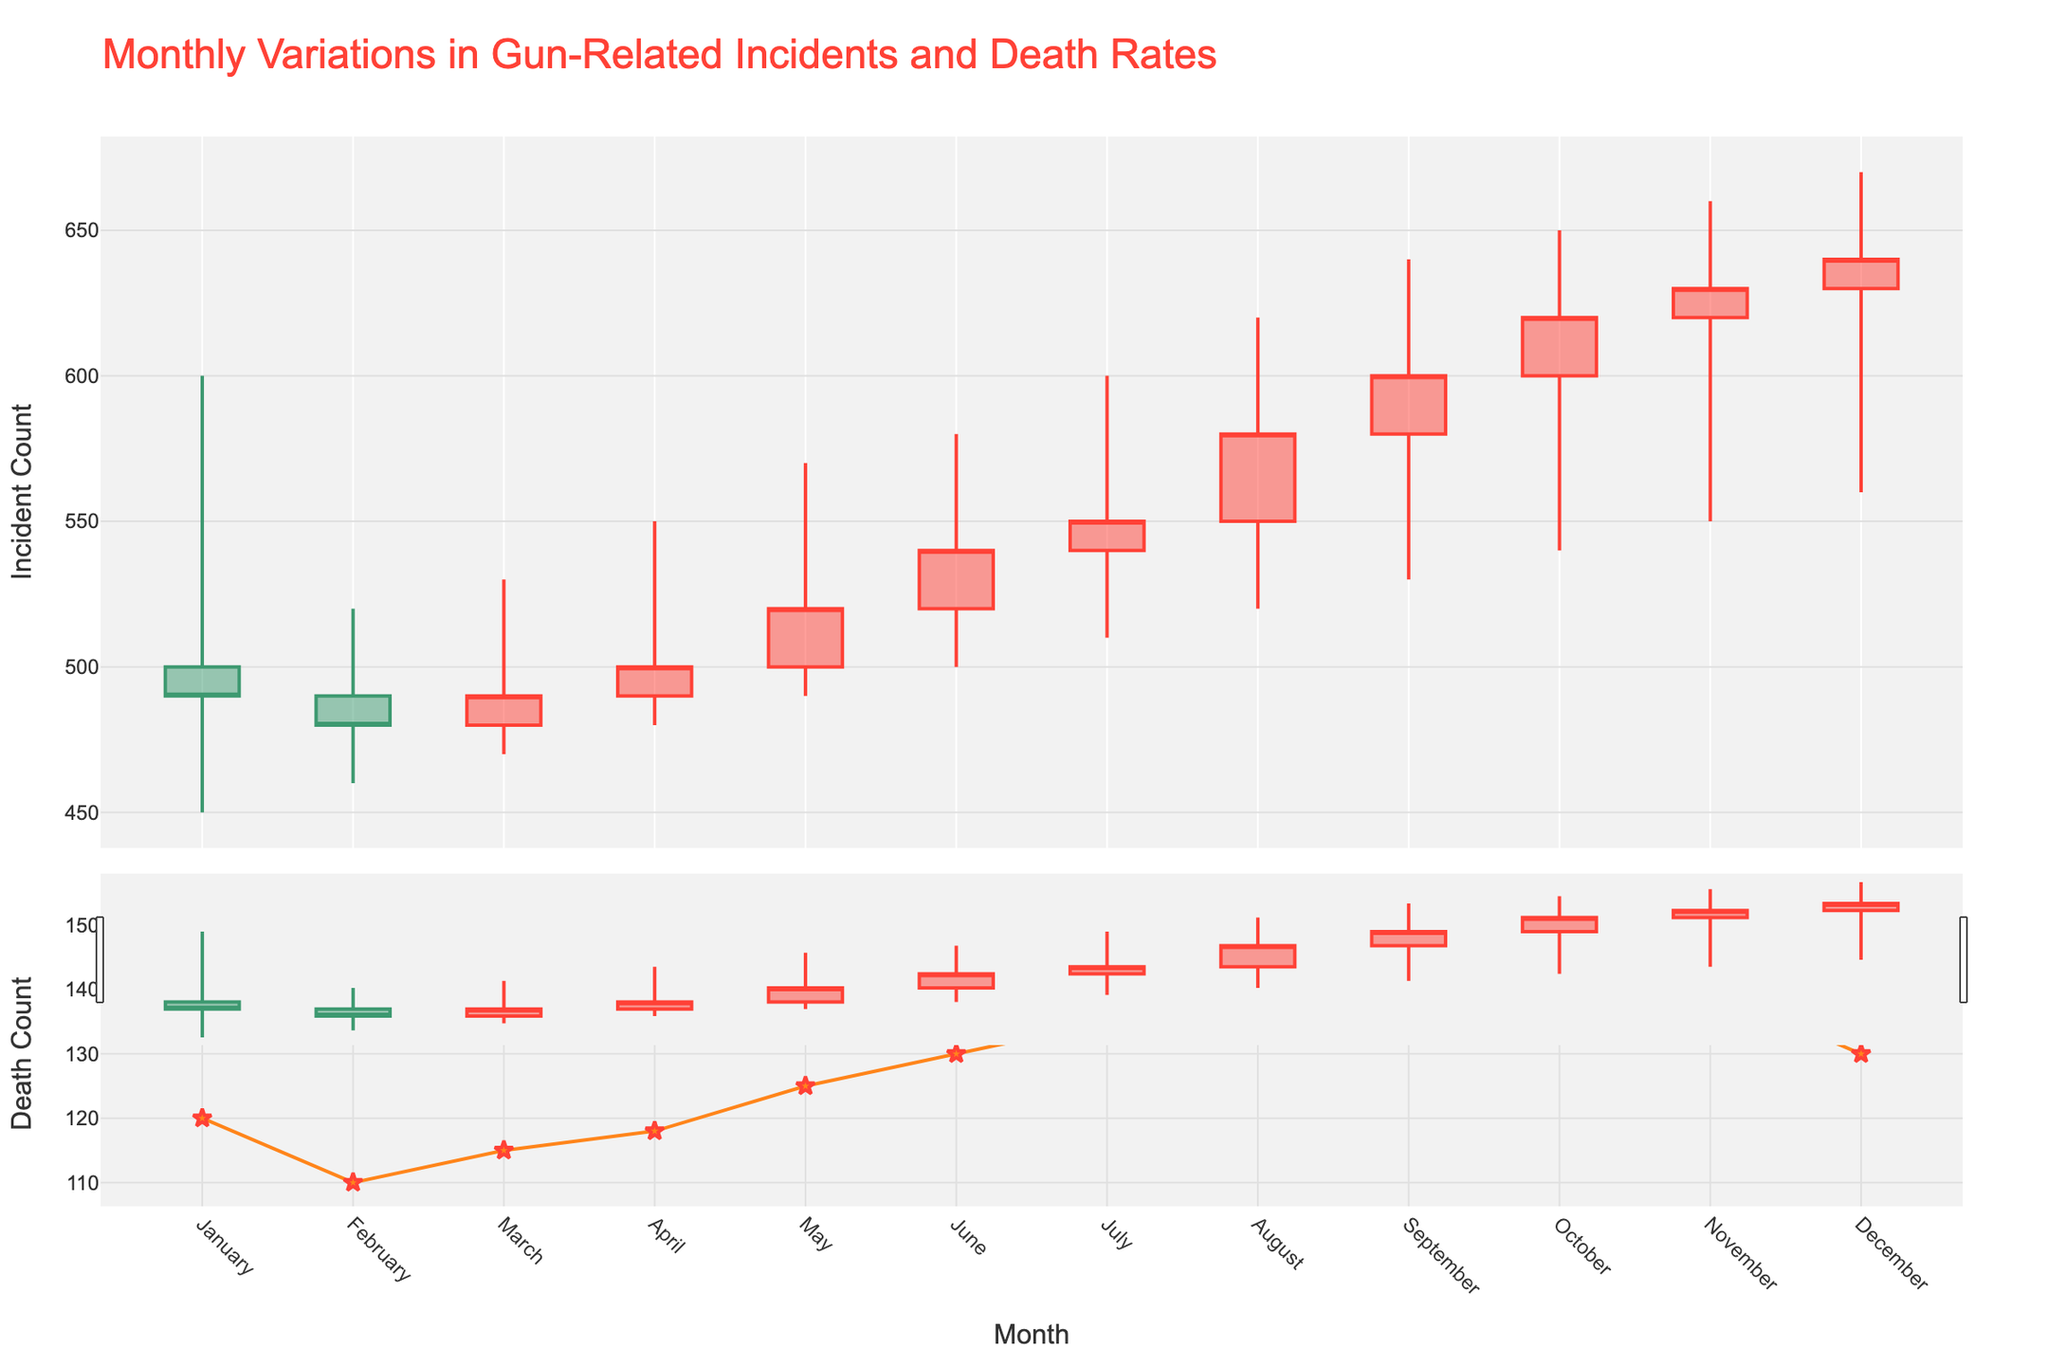what is the title of the figure? The title of the figure is positioned at the top of the plot and is prominently displayed. It helps identify the main subject of the visualization.
Answer: Monthly Variations in Gun-Related Incidents and Death Rates what is the color of the increasing candlestick lines? The increasing candlestick lines' color signifies the months where the closing number of incidents is higher than the opening number. These lines are colored in a distinguishable bright shade.
Answer: Red which month has the highest death count? To find the month with the highest death count, look at the scatter plot in the second row that marks the gun-related deaths for each month. Identify the month with the highest marker point.
Answer: October what is the difference between the high and low values in September? The high and low values in September can be found from the candlestick plot. Subtract the low value from the high value to get the difference.
Answer: 110 which months have more than 130 gun-related deaths? By examining the second plot with the death counts, identify all months where the death counts are above 130. Multiple markers make it easy to spot these months.
Answer: August, September, October, November how much did the closing number of incidents increase from December to January? To find the increase in the number of incidents from December to January, look at the closing values for both months and subtract the January value from the December value.
Answer: -150, meaning a decrease what trend can be observed in the number of gun-related deaths over the months? Study the pattern of the markers representing gun-related deaths in the scatter plot over time to understand any increasing or decreasing trend.
Answer: Increasing until October, then slightly decreasing how do the high values in May and June compare? To compare the high values of May and June, look at the corresponding peaks in the candlestick plot and note their values.
Answer: June is higher what is the average closing value over the entire year? To calculate the average closing value, sum all the closing values for each month and divide by the number of months (12) to get the average.
Answer: (490 + 480 + 490 + 500 + 520 + 540 + 550 + 580 + 600 + 620 + 630 + 640) / 12 = 538.33 which month had the smallest range between the high and low values? To find the month with the smallest range, examine each candlestick's high and low values, calculate their differences, and determine which month has the smallest value.
Answer: February 